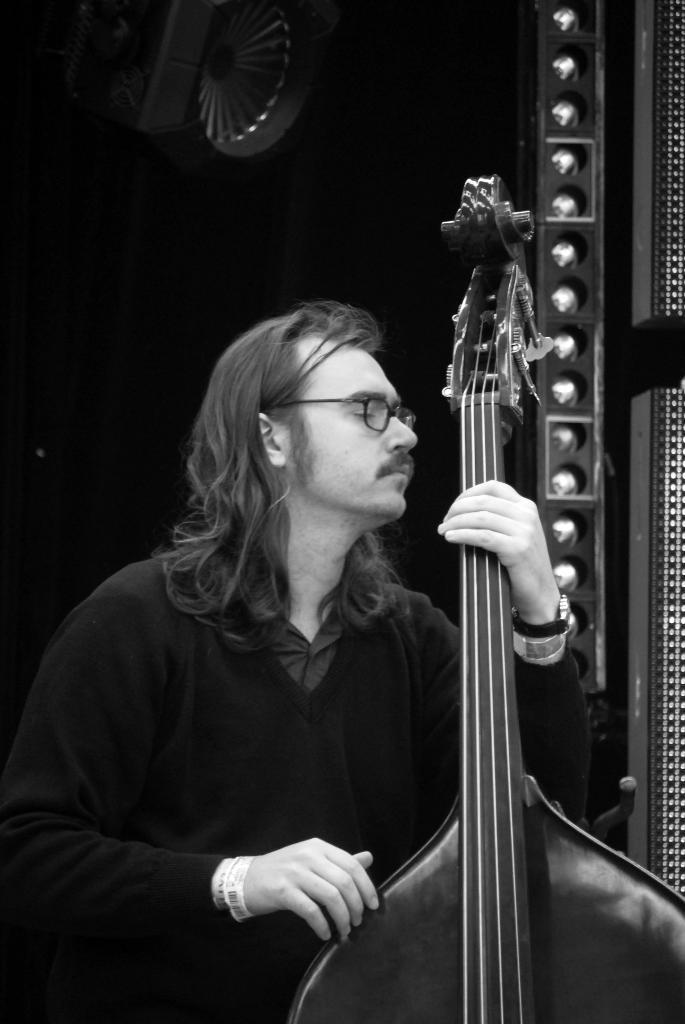What is the main subject of the image? The main subject of the image is a man. What is the man holding in the image? The man is holding a musical instrument. What can be seen in the background of the image? There is a wall in the background of the image. What type of vegetable is the man trying to expand in the image? There is no vegetable present in the image, and the man is not trying to expand anything. 